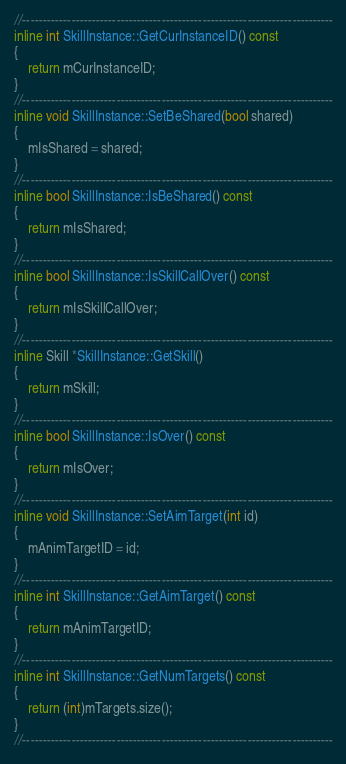Convert code to text. <code><loc_0><loc_0><loc_500><loc_500><_C++_>//----------------------------------------------------------------------------
inline int SkillInstance::GetCurInstanceID() const
{
	return mCurInstanceID;
}
//----------------------------------------------------------------------------
inline void SkillInstance::SetBeShared(bool shared)
{
	mIsShared = shared;
}
//----------------------------------------------------------------------------
inline bool SkillInstance::IsBeShared() const
{
	return mIsShared;
}
//----------------------------------------------------------------------------
inline bool SkillInstance::IsSkillCallOver() const
{
	return mIsSkillCallOver;
}
//----------------------------------------------------------------------------
inline Skill *SkillInstance::GetSkill()
{
	return mSkill;
}
//----------------------------------------------------------------------------
inline bool SkillInstance::IsOver() const
{
	return mIsOver;
}
//----------------------------------------------------------------------------
inline void SkillInstance::SetAimTarget(int id)
{
	mAnimTargetID = id;
}
//----------------------------------------------------------------------------
inline int SkillInstance::GetAimTarget() const
{
	return mAnimTargetID;
}
//----------------------------------------------------------------------------
inline int SkillInstance::GetNumTargets() const
{
	return (int)mTargets.size();
}
//----------------------------------------------------------------------------</code> 